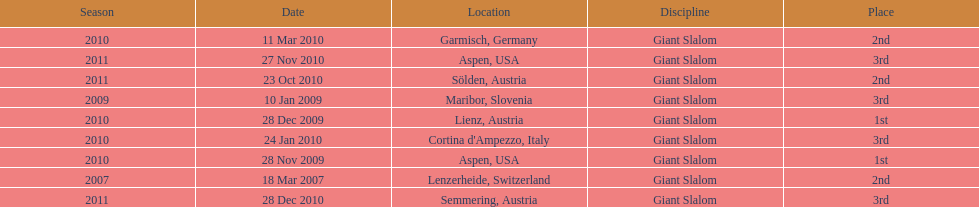Where was her first win? Aspen, USA. 